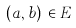<formula> <loc_0><loc_0><loc_500><loc_500>( a , b ) \, \in { E }</formula> 